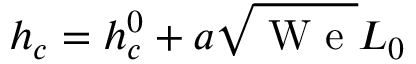Convert formula to latex. <formula><loc_0><loc_0><loc_500><loc_500>h _ { c } = h _ { c } ^ { 0 } + a \sqrt { W } e L _ { 0 }</formula> 